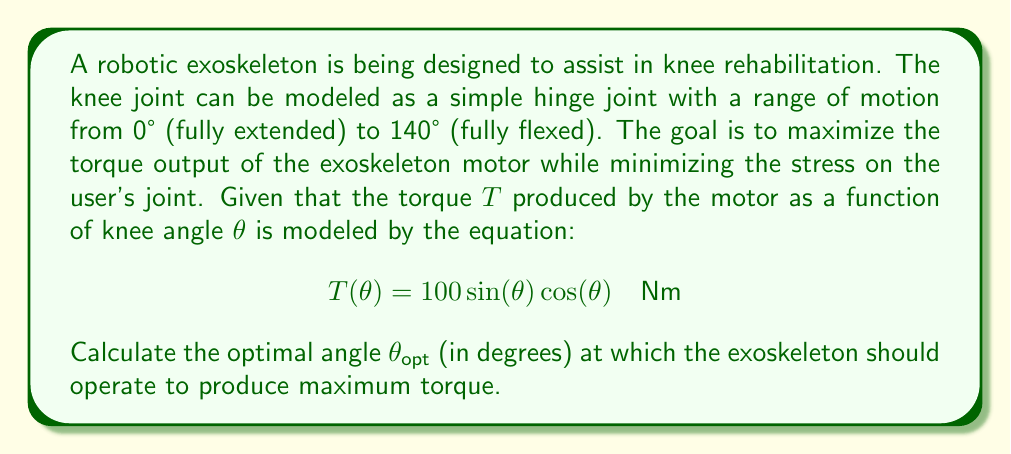What is the answer to this math problem? To find the optimal angle for maximum torque, we need to follow these steps:

1) The torque function is given by:
   $$T(\theta) = 100 \sin(\theta) \cos(\theta) \quad \text{Nm}$$

2) To find the maximum, we need to differentiate $T(\theta)$ with respect to $\theta$ and set it to zero:
   $$\frac{dT}{d\theta} = 100[\cos^2(\theta) - \sin^2(\theta)] = 0$$

3) Using the trigonometric identity $\cos^2(\theta) - \sin^2(\theta) = \cos(2\theta)$, we get:
   $$100\cos(2\theta) = 0$$

4) Solving this equation:
   $$\cos(2\theta) = 0$$
   $$2\theta = \arccos(0) = \frac{\pi}{2} \quad \text{or} \quad \frac{3\pi}{2}$$

5) Solving for $\theta$:
   $$\theta = \frac{\pi}{4} \quad \text{or} \quad \frac{3\pi}{4}$$

6) Converting to degrees:
   $$\theta = 45° \quad \text{or} \quad 135°$$

7) To determine which of these gives the maximum (rather than minimum) torque, we can check the second derivative or simply evaluate $T(\theta)$ at both points:

   $$T(45°) = 100 \sin(45°) \cos(45°) = 50 \quad \text{Nm}$$
   $$T(135°) = 100 \sin(135°) \cos(135°) = -50 \quad \text{Nm}$$

Therefore, the optimal angle for maximum torque is 45°.
Answer: 45° 